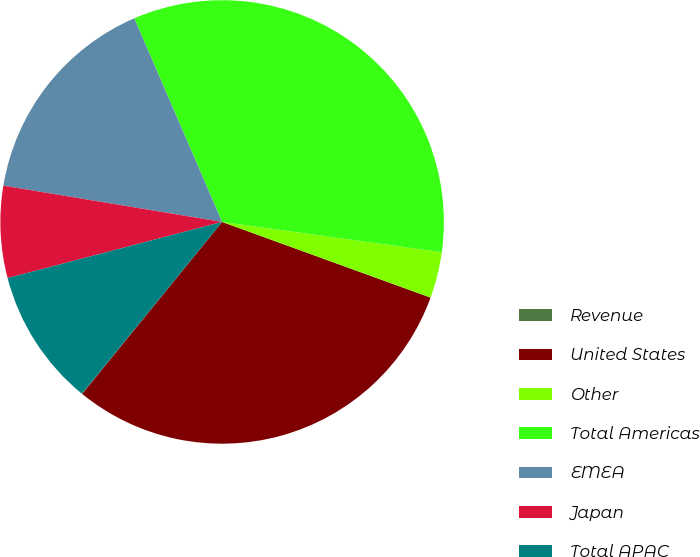<chart> <loc_0><loc_0><loc_500><loc_500><pie_chart><fcel>Revenue<fcel>United States<fcel>Other<fcel>Total Americas<fcel>EMEA<fcel>Japan<fcel>Total APAC<nl><fcel>0.02%<fcel>30.33%<fcel>3.36%<fcel>33.66%<fcel>15.9%<fcel>6.69%<fcel>10.03%<nl></chart> 